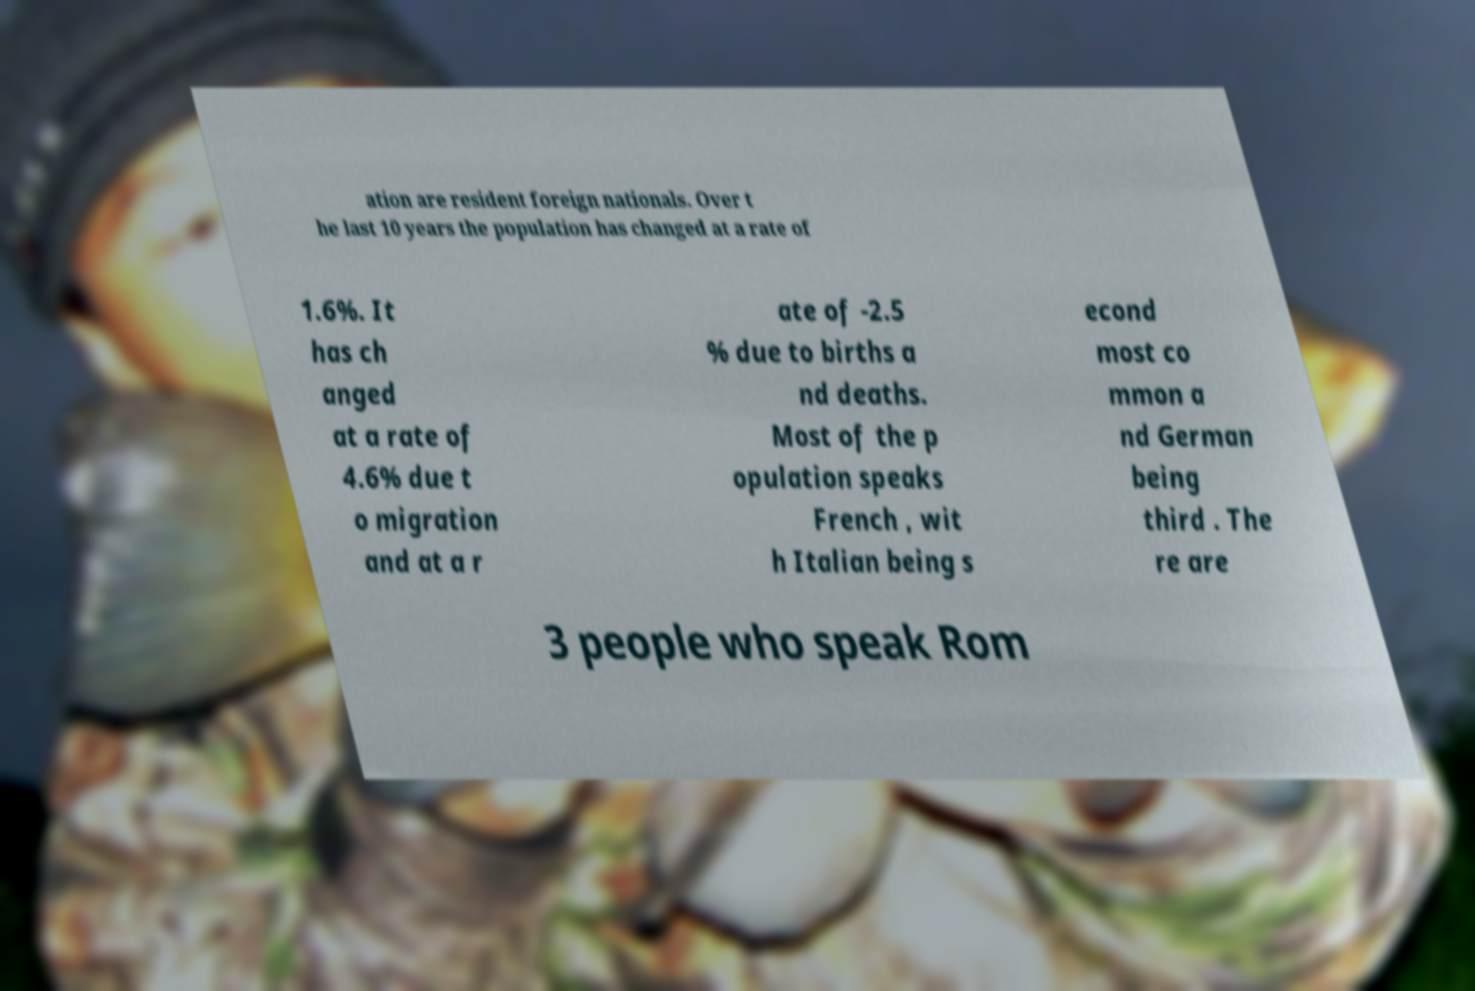For documentation purposes, I need the text within this image transcribed. Could you provide that? ation are resident foreign nationals. Over t he last 10 years the population has changed at a rate of 1.6%. It has ch anged at a rate of 4.6% due t o migration and at a r ate of -2.5 % due to births a nd deaths. Most of the p opulation speaks French , wit h Italian being s econd most co mmon a nd German being third . The re are 3 people who speak Rom 